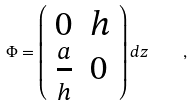<formula> <loc_0><loc_0><loc_500><loc_500>\Phi = \left ( \begin{array} { l l } { 0 } & { h } \\ { { { \frac { a } { h } } } } & { 0 } \end{array} \right ) d z \quad ,</formula> 